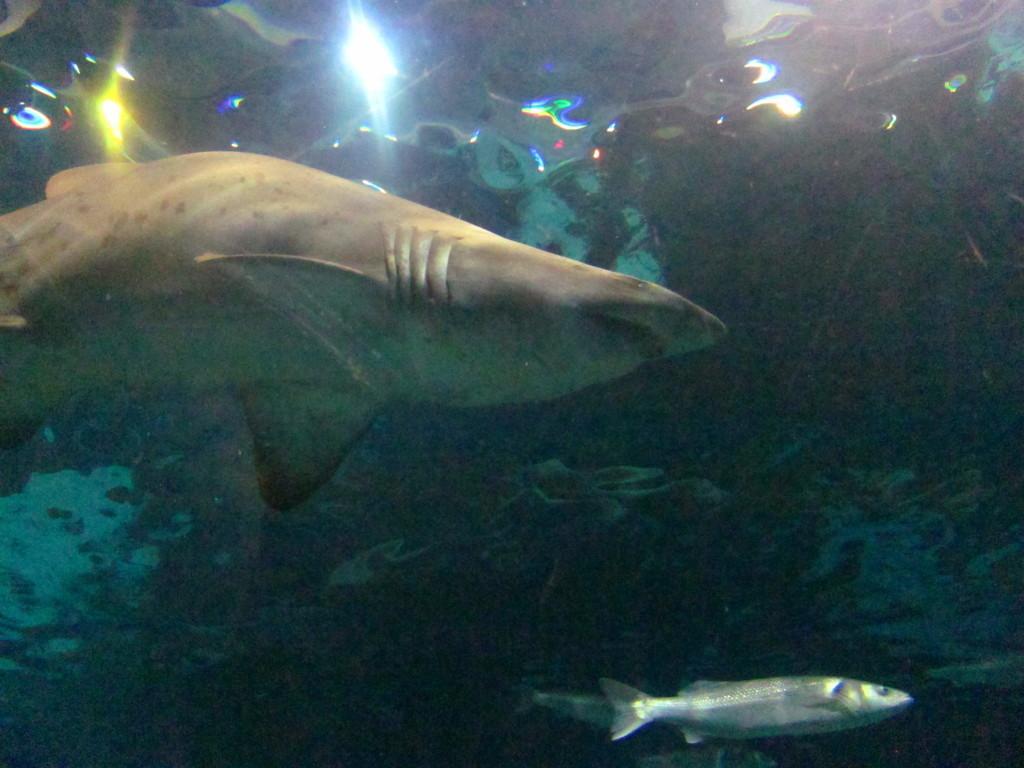Please provide a concise description of this image. In this picture there are fishes and there are plants in the water. 